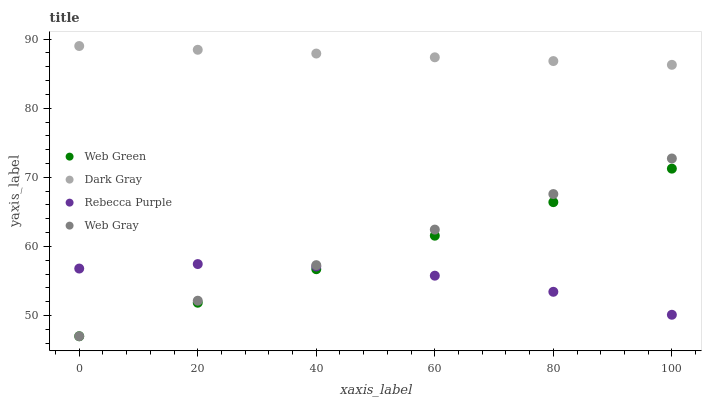Does Rebecca Purple have the minimum area under the curve?
Answer yes or no. Yes. Does Dark Gray have the maximum area under the curve?
Answer yes or no. Yes. Does Web Gray have the minimum area under the curve?
Answer yes or no. No. Does Web Gray have the maximum area under the curve?
Answer yes or no. No. Is Web Gray the smoothest?
Answer yes or no. Yes. Is Rebecca Purple the roughest?
Answer yes or no. Yes. Is Rebecca Purple the smoothest?
Answer yes or no. No. Is Web Gray the roughest?
Answer yes or no. No. Does Web Gray have the lowest value?
Answer yes or no. Yes. Does Rebecca Purple have the lowest value?
Answer yes or no. No. Does Dark Gray have the highest value?
Answer yes or no. Yes. Does Web Gray have the highest value?
Answer yes or no. No. Is Rebecca Purple less than Dark Gray?
Answer yes or no. Yes. Is Dark Gray greater than Web Gray?
Answer yes or no. Yes. Does Web Gray intersect Web Green?
Answer yes or no. Yes. Is Web Gray less than Web Green?
Answer yes or no. No. Is Web Gray greater than Web Green?
Answer yes or no. No. Does Rebecca Purple intersect Dark Gray?
Answer yes or no. No. 